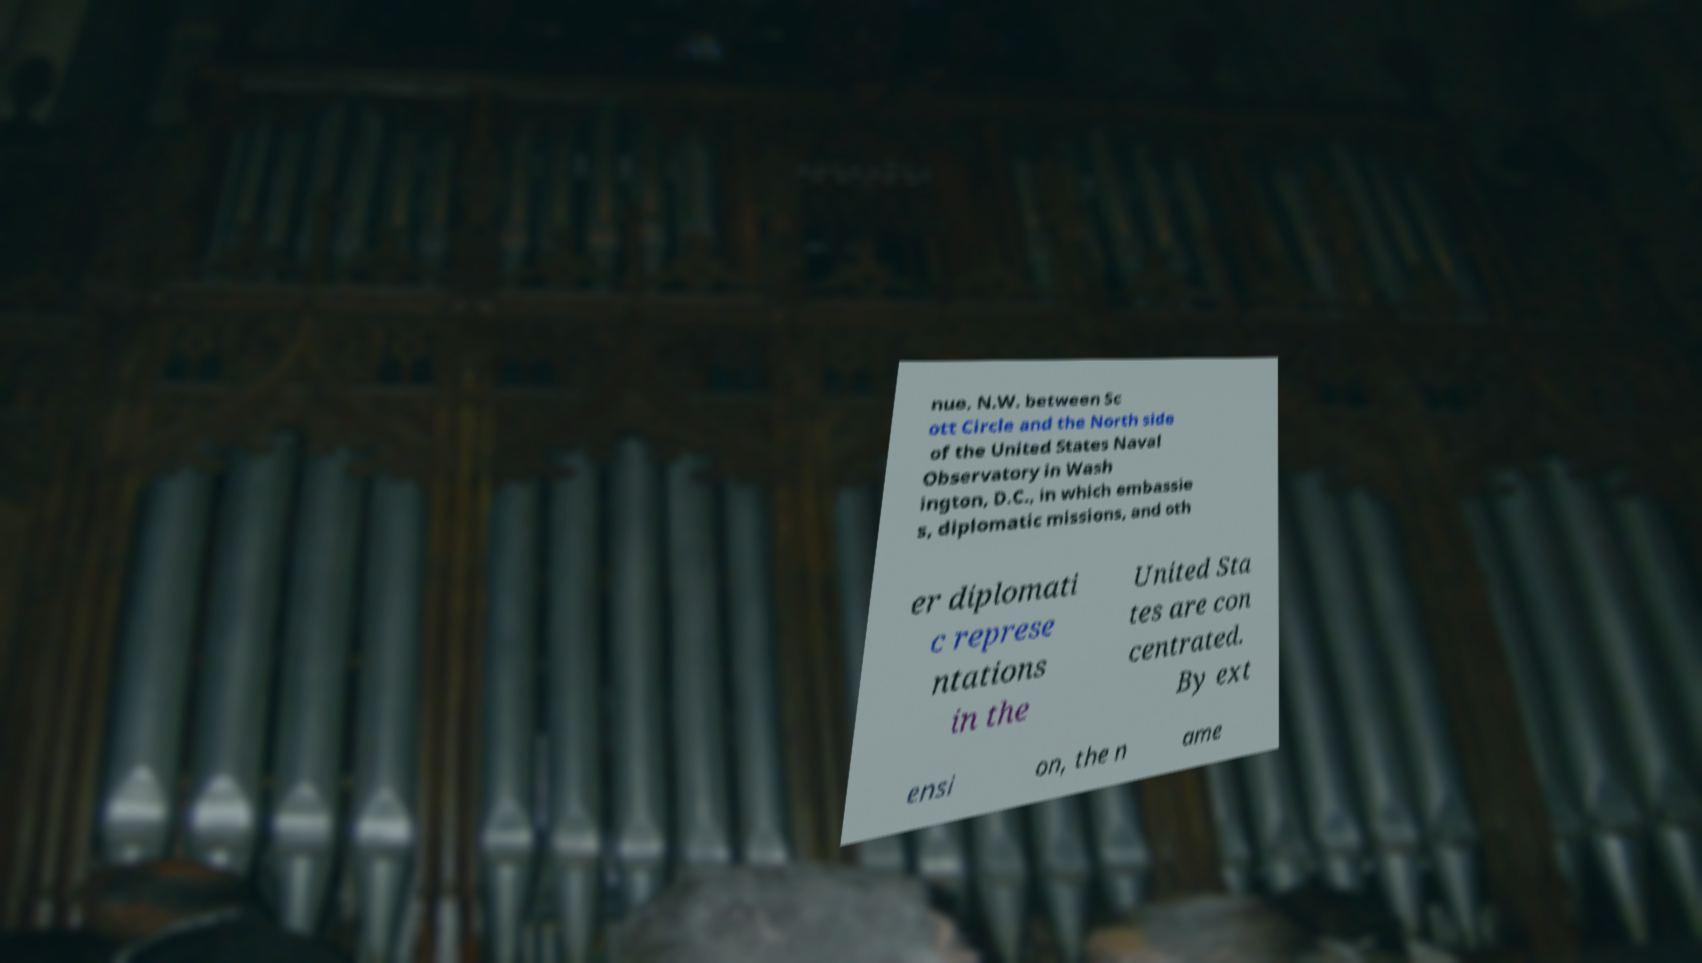There's text embedded in this image that I need extracted. Can you transcribe it verbatim? nue, N.W. between Sc ott Circle and the North side of the United States Naval Observatory in Wash ington, D.C., in which embassie s, diplomatic missions, and oth er diplomati c represe ntations in the United Sta tes are con centrated. By ext ensi on, the n ame 